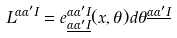Convert formula to latex. <formula><loc_0><loc_0><loc_500><loc_500>L ^ { \alpha \alpha ^ { \prime } I } = e _ { \underline { \alpha } \underline { { { \alpha ^ { \prime } } } } \underline { I } } ^ { \alpha \alpha ^ { \prime } I } ( x , \theta ) d \theta ^ { \underline { \alpha } \underline { { { \alpha ^ { \prime } } } } \underline { I } }</formula> 